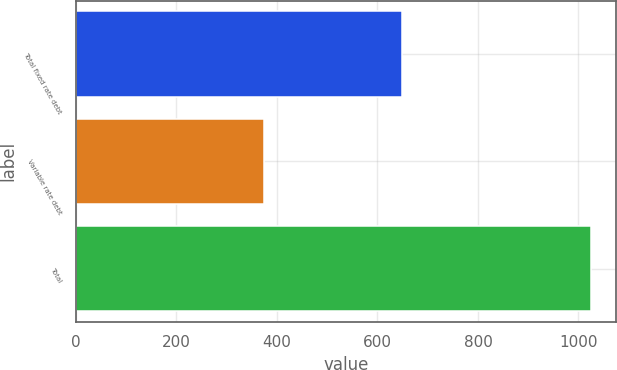<chart> <loc_0><loc_0><loc_500><loc_500><bar_chart><fcel>Total fixed rate debt<fcel>Variable rate debt<fcel>Total<nl><fcel>649<fcel>375<fcel>1024<nl></chart> 